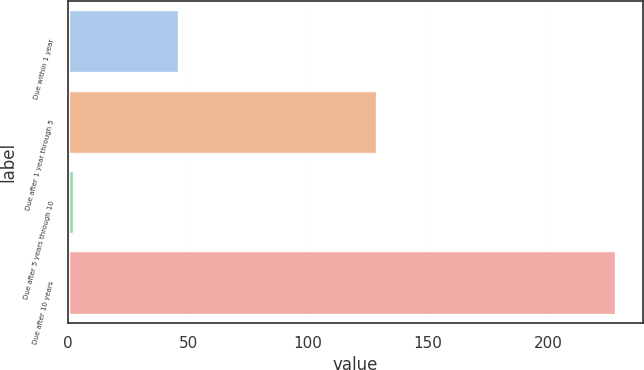<chart> <loc_0><loc_0><loc_500><loc_500><bar_chart><fcel>Due within 1 year<fcel>Due after 1 year through 5<fcel>Due after 5 years through 10<fcel>Due after 10 years<nl><fcel>46.2<fcel>128.7<fcel>2.5<fcel>228.2<nl></chart> 